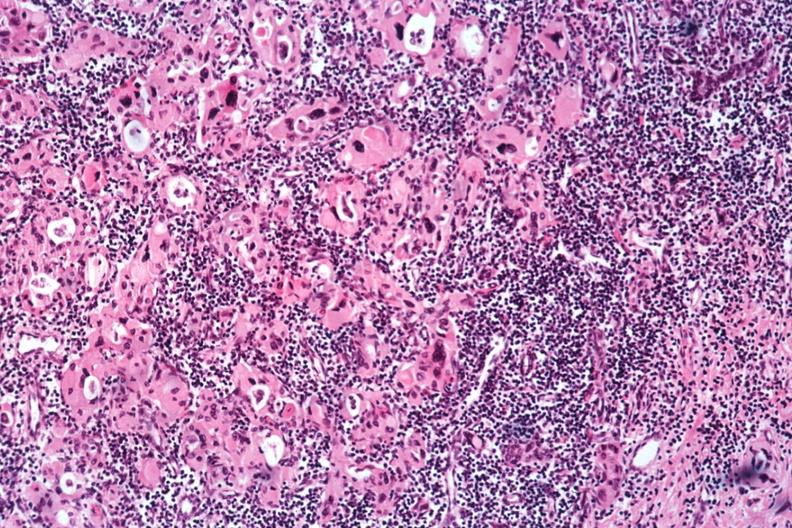does stillborn cord around neck show med bizarre hurthle type cells with lymphocytic infiltrate no recognizable thyroid tissue?
Answer the question using a single word or phrase. No 